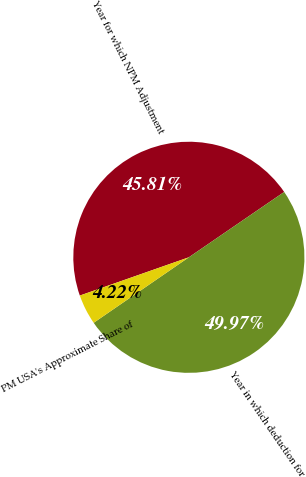Convert chart. <chart><loc_0><loc_0><loc_500><loc_500><pie_chart><fcel>Year for which NPM Adjustment<fcel>Year in which deduction for<fcel>PM USA's Approximate Share of<nl><fcel>45.81%<fcel>49.97%<fcel>4.22%<nl></chart> 